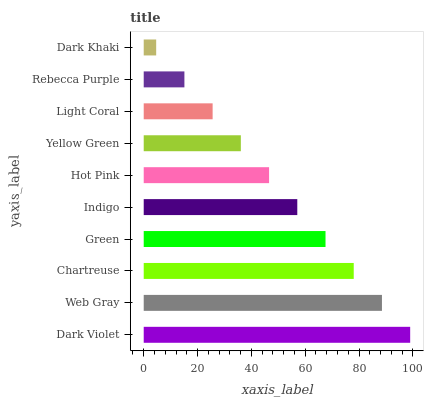Is Dark Khaki the minimum?
Answer yes or no. Yes. Is Dark Violet the maximum?
Answer yes or no. Yes. Is Web Gray the minimum?
Answer yes or no. No. Is Web Gray the maximum?
Answer yes or no. No. Is Dark Violet greater than Web Gray?
Answer yes or no. Yes. Is Web Gray less than Dark Violet?
Answer yes or no. Yes. Is Web Gray greater than Dark Violet?
Answer yes or no. No. Is Dark Violet less than Web Gray?
Answer yes or no. No. Is Indigo the high median?
Answer yes or no. Yes. Is Hot Pink the low median?
Answer yes or no. Yes. Is Dark Khaki the high median?
Answer yes or no. No. Is Yellow Green the low median?
Answer yes or no. No. 